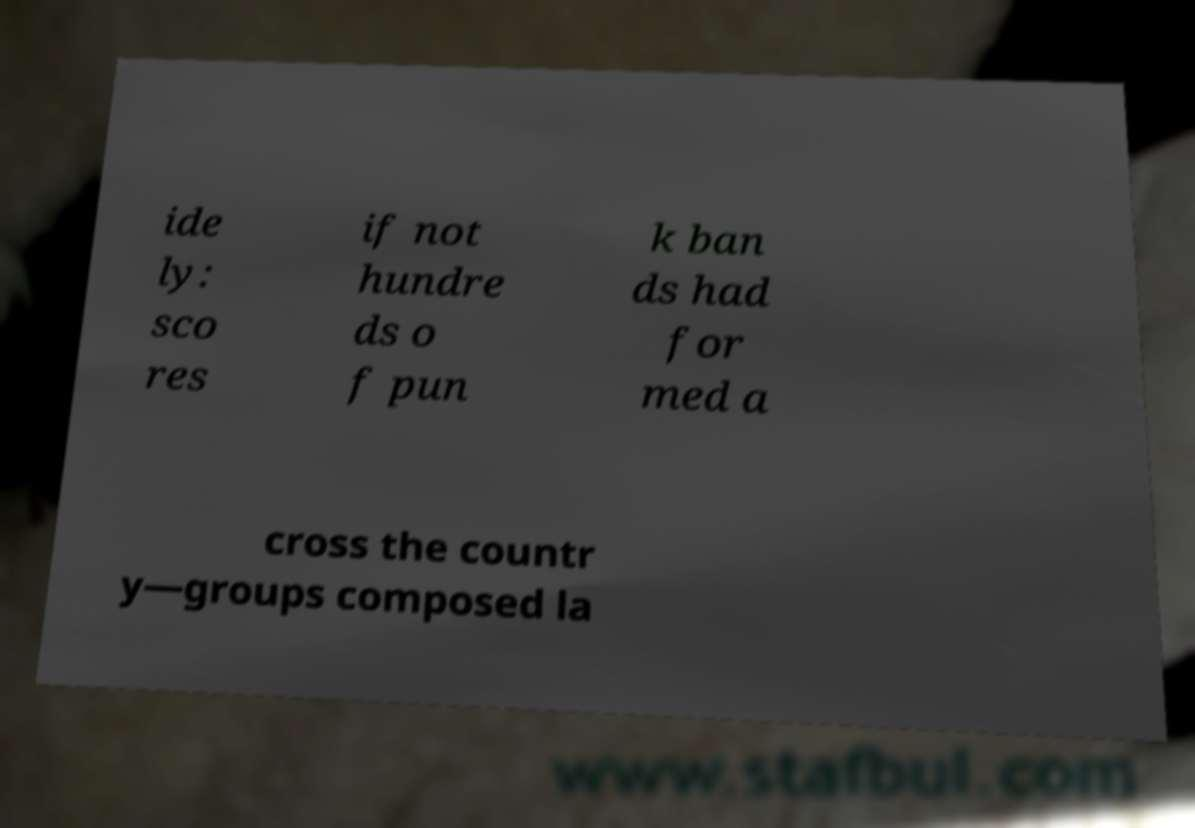What messages or text are displayed in this image? I need them in a readable, typed format. ide ly: sco res if not hundre ds o f pun k ban ds had for med a cross the countr y—groups composed la 